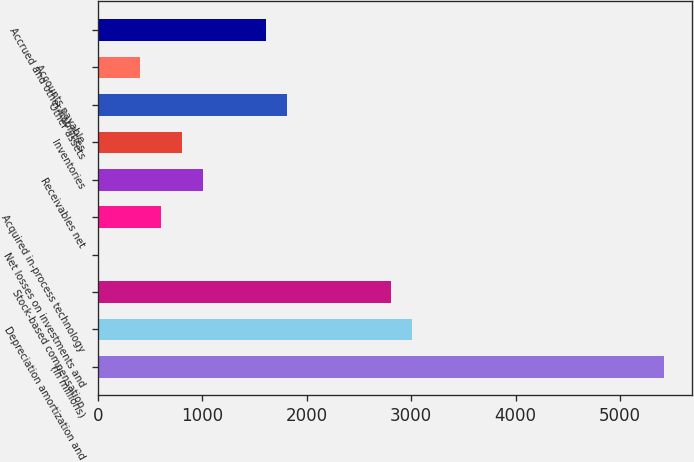Convert chart. <chart><loc_0><loc_0><loc_500><loc_500><bar_chart><fcel>(In millions)<fcel>Depreciation amortization and<fcel>Stock-based compensation<fcel>Net losses on investments and<fcel>Acquired in-process technology<fcel>Receivables net<fcel>Inventories<fcel>Other assets<fcel>Accounts payable<fcel>Accrued and other liabilities<nl><fcel>5417.2<fcel>3010<fcel>2809.4<fcel>1<fcel>602.8<fcel>1004<fcel>803.4<fcel>1806.4<fcel>402.2<fcel>1605.8<nl></chart> 